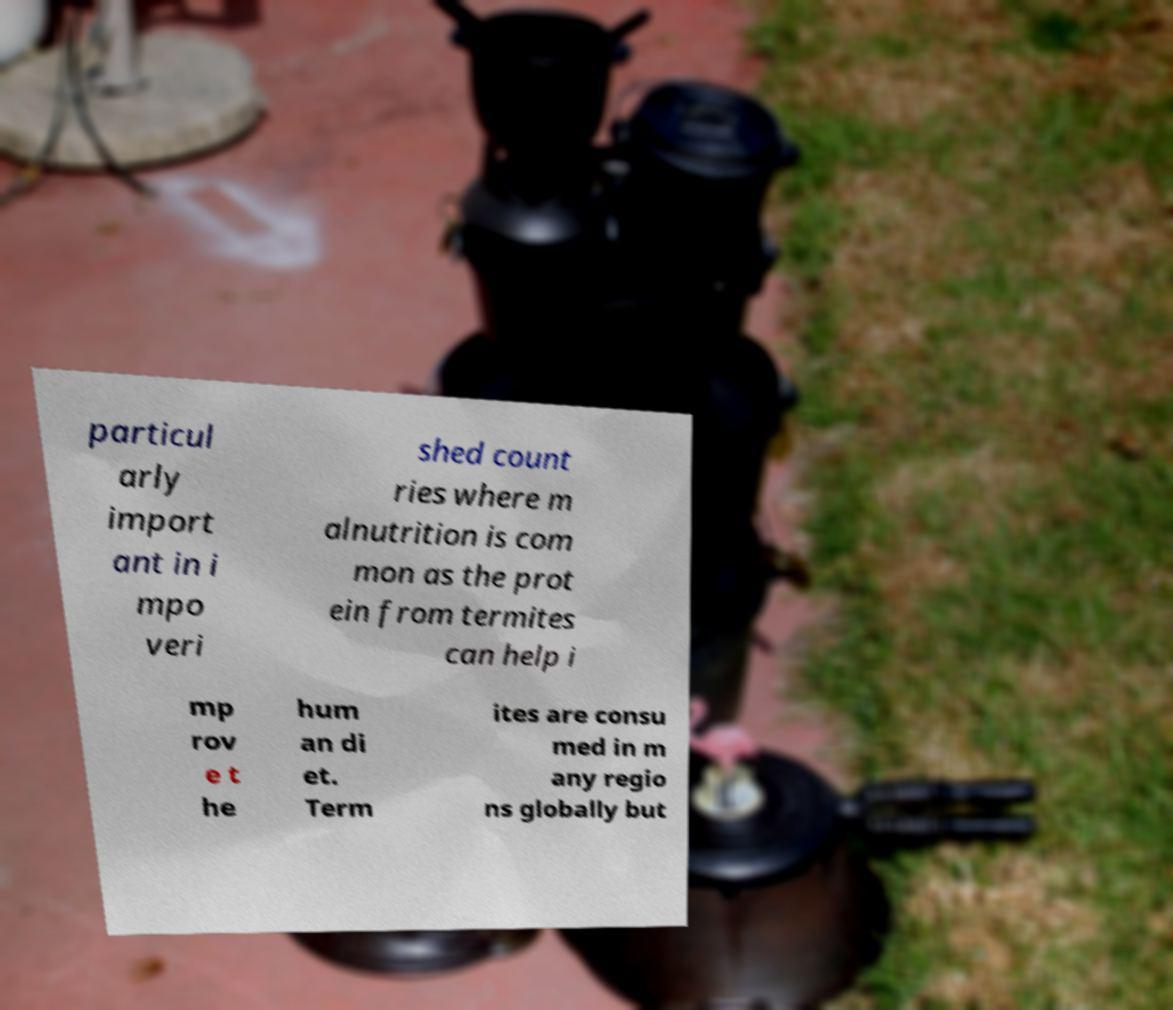Could you extract and type out the text from this image? particul arly import ant in i mpo veri shed count ries where m alnutrition is com mon as the prot ein from termites can help i mp rov e t he hum an di et. Term ites are consu med in m any regio ns globally but 